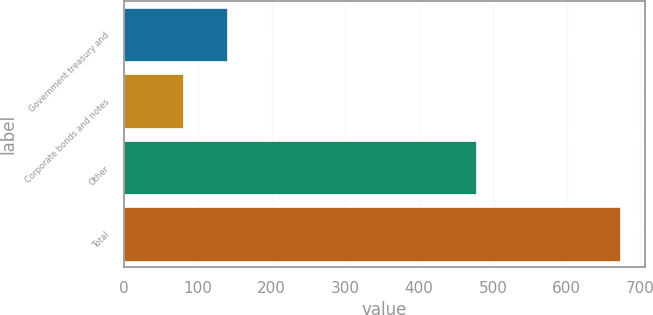Convert chart. <chart><loc_0><loc_0><loc_500><loc_500><bar_chart><fcel>Government treasury and<fcel>Corporate bonds and notes<fcel>Other<fcel>Total<nl><fcel>139.58<fcel>80.4<fcel>477<fcel>672.2<nl></chart> 